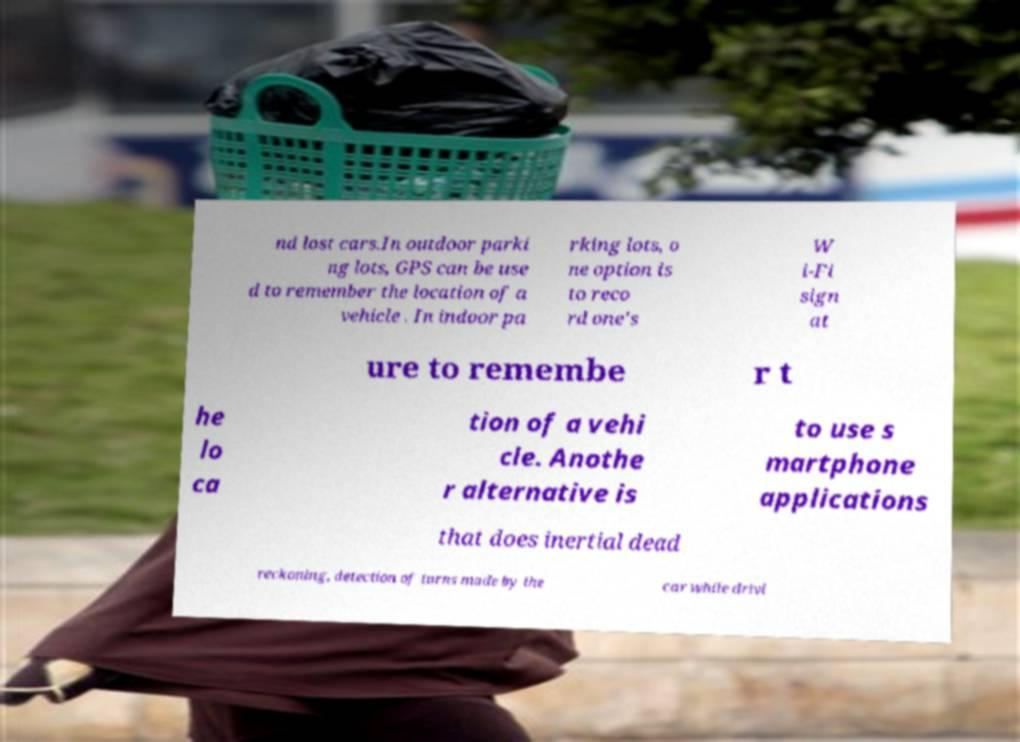Can you accurately transcribe the text from the provided image for me? nd lost cars.In outdoor parki ng lots, GPS can be use d to remember the location of a vehicle . In indoor pa rking lots, o ne option is to reco rd one's W i-Fi sign at ure to remembe r t he lo ca tion of a vehi cle. Anothe r alternative is to use s martphone applications that does inertial dead reckoning, detection of turns made by the car while drivi 